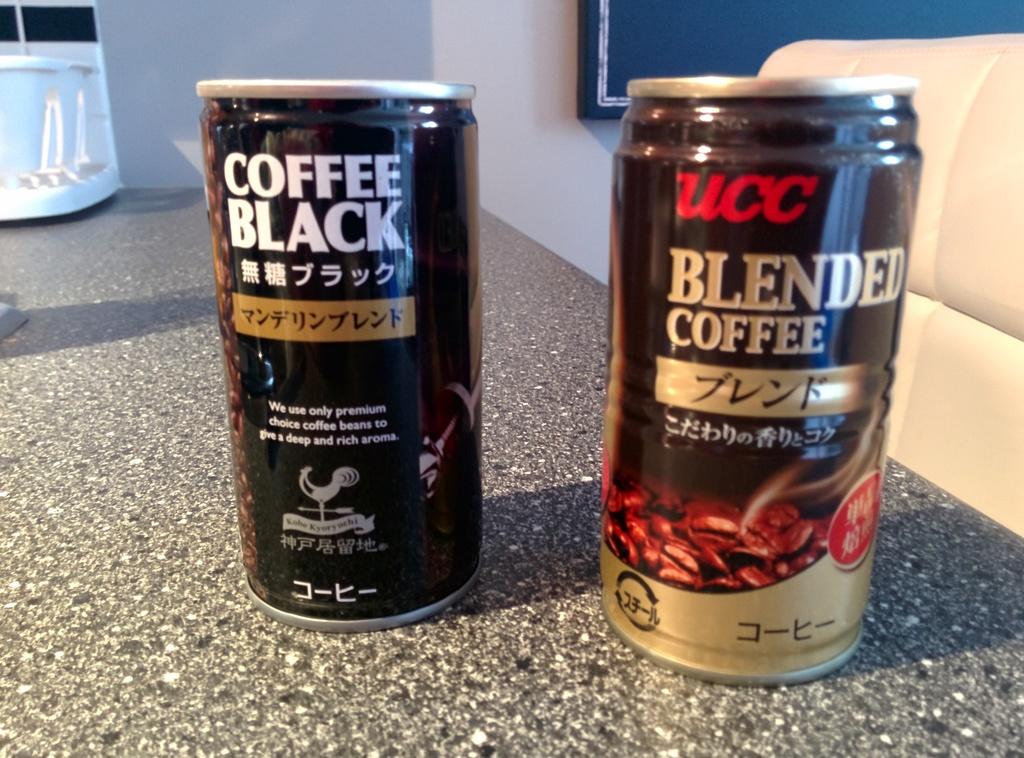What kind of coffee is on teh right?
Your answer should be very brief. Blended coffee. 